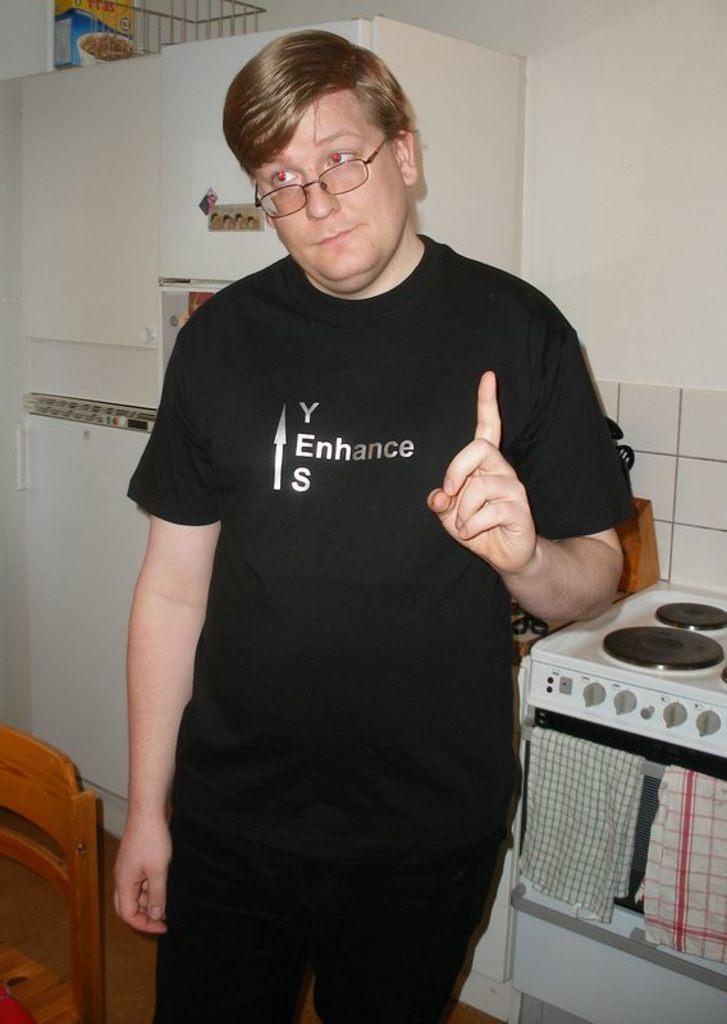What does the man's shirt say?
Your response must be concise. Y enhance s. What does the first letters each spell together?
Your response must be concise. Yes. 